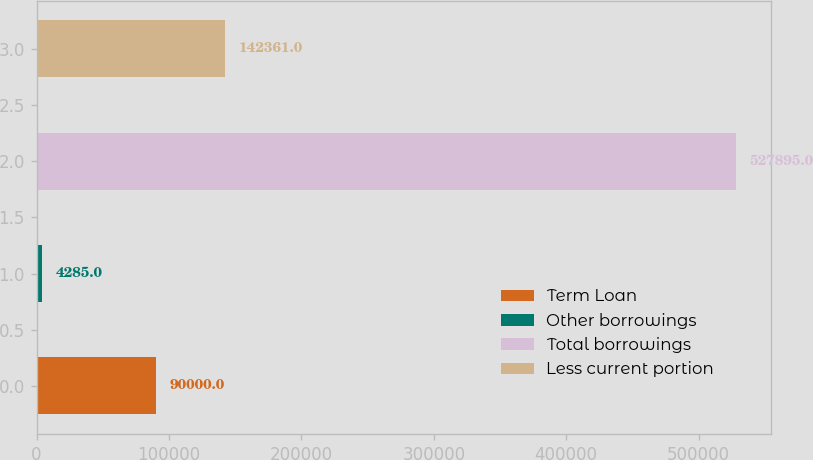Convert chart. <chart><loc_0><loc_0><loc_500><loc_500><bar_chart><fcel>Term Loan<fcel>Other borrowings<fcel>Total borrowings<fcel>Less current portion<nl><fcel>90000<fcel>4285<fcel>527895<fcel>142361<nl></chart> 